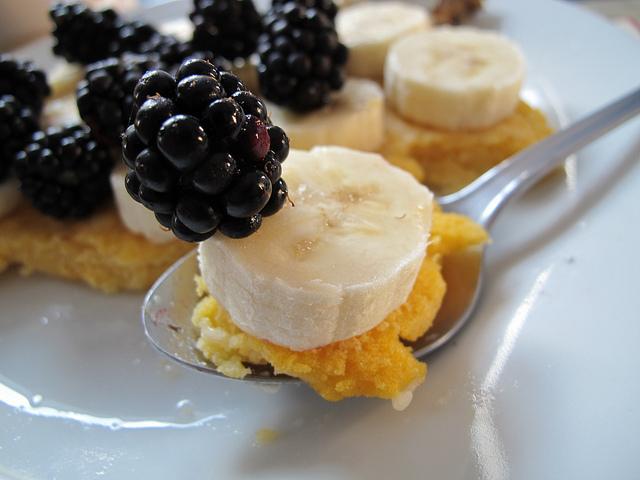Are these sweet blackberries or sour?
Give a very brief answer. Sweet. When are foods like this eaten?
Keep it brief. Breakfast. Is this a salty food?
Write a very short answer. No. Which of these foods could be made into wine?
Be succinct. Blackberries. 